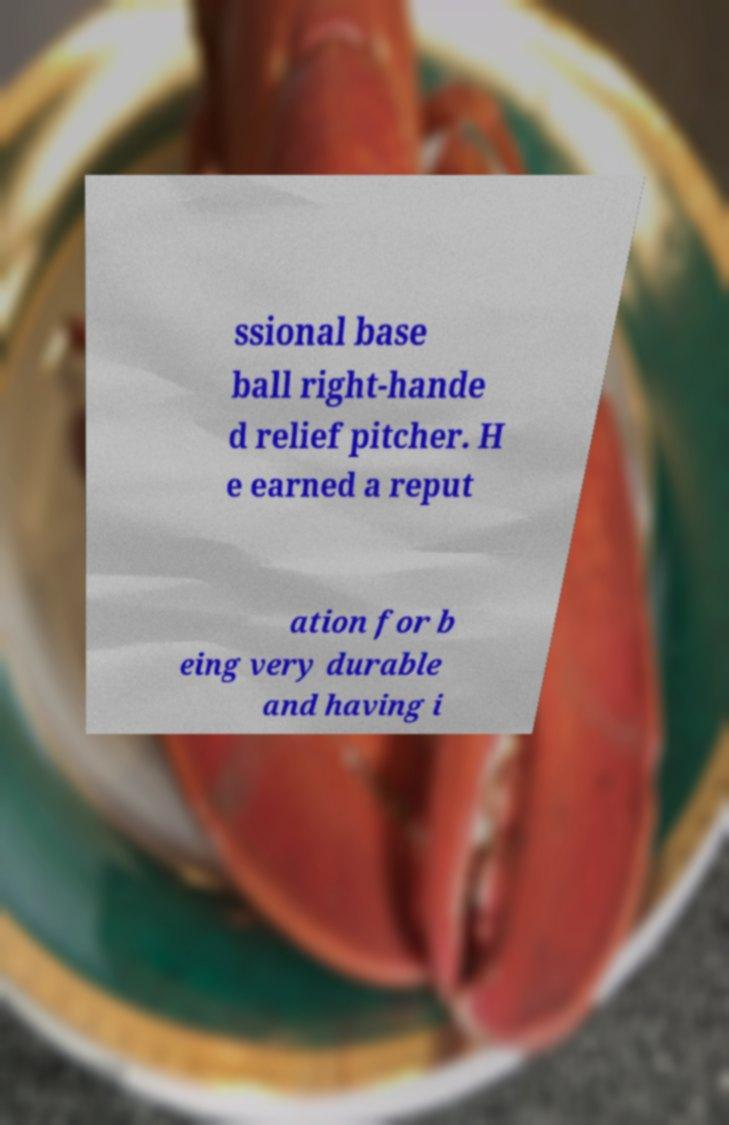For documentation purposes, I need the text within this image transcribed. Could you provide that? ssional base ball right-hande d relief pitcher. H e earned a reput ation for b eing very durable and having i 